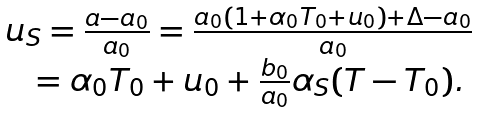Convert formula to latex. <formula><loc_0><loc_0><loc_500><loc_500>\begin{array} { l } u _ { S } = \frac { a - a _ { 0 } } { a _ { 0 } } = \frac { a _ { 0 } ( 1 + \alpha _ { 0 } T _ { 0 } + u _ { 0 } ) + \Delta - a _ { 0 } } { a _ { 0 } } \\ \quad = \alpha _ { 0 } T _ { 0 } + u _ { 0 } + \frac { b _ { 0 } } { a _ { 0 } } \alpha _ { S } ( T - T _ { 0 } ) . \end{array}</formula> 